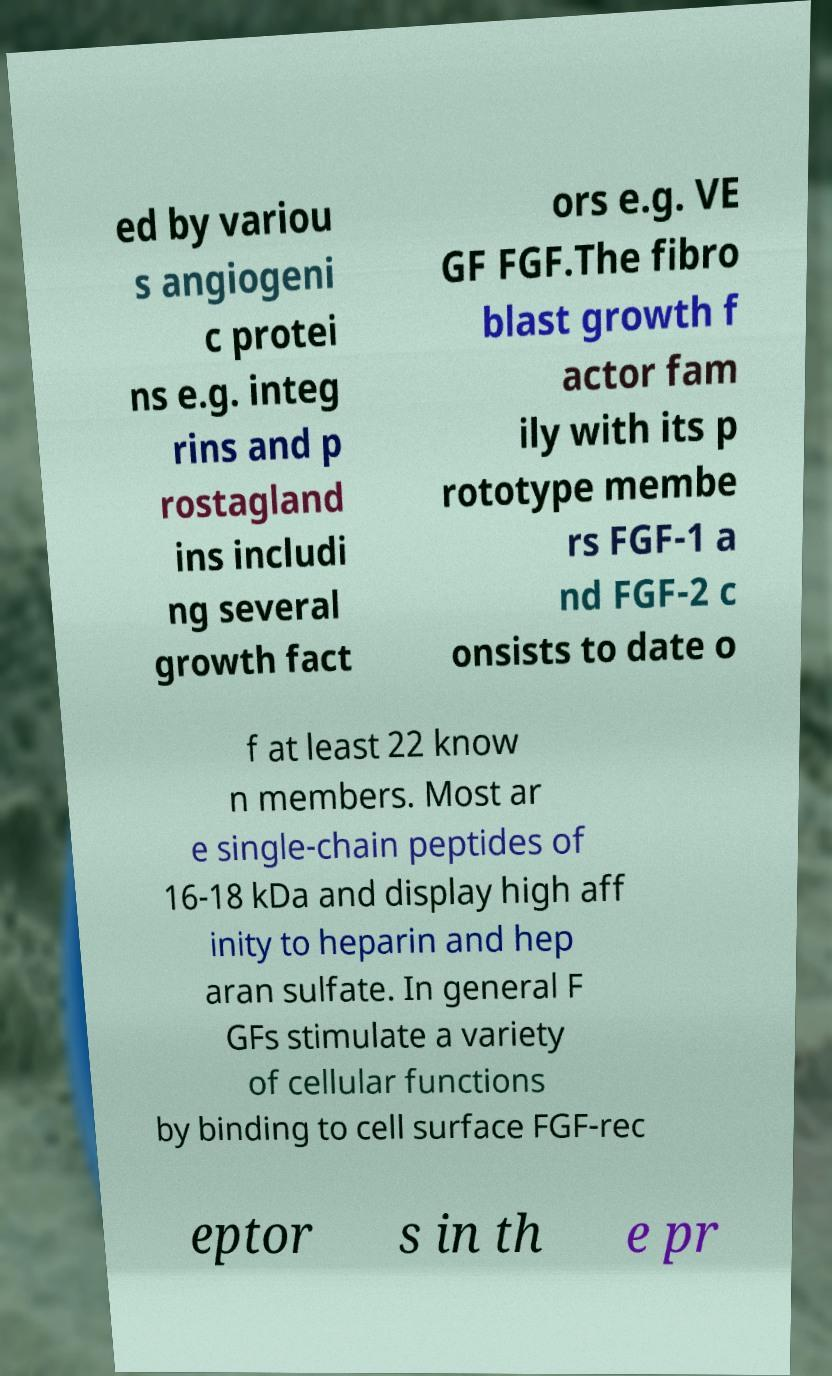For documentation purposes, I need the text within this image transcribed. Could you provide that? ed by variou s angiogeni c protei ns e.g. integ rins and p rostagland ins includi ng several growth fact ors e.g. VE GF FGF.The fibro blast growth f actor fam ily with its p rototype membe rs FGF-1 a nd FGF-2 c onsists to date o f at least 22 know n members. Most ar e single-chain peptides of 16-18 kDa and display high aff inity to heparin and hep aran sulfate. In general F GFs stimulate a variety of cellular functions by binding to cell surface FGF-rec eptor s in th e pr 